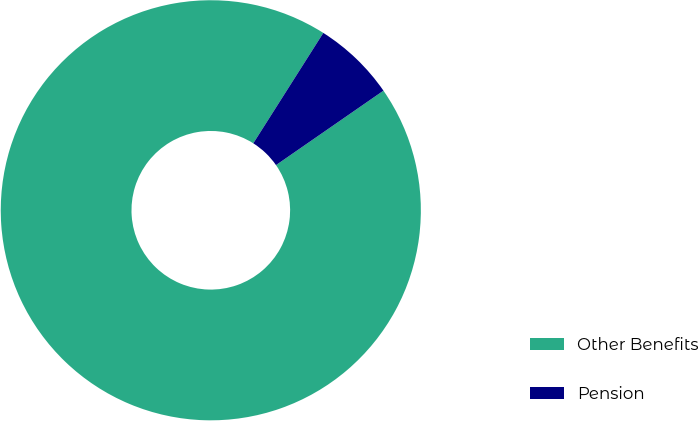Convert chart. <chart><loc_0><loc_0><loc_500><loc_500><pie_chart><fcel>Other Benefits<fcel>Pension<nl><fcel>93.64%<fcel>6.36%<nl></chart> 